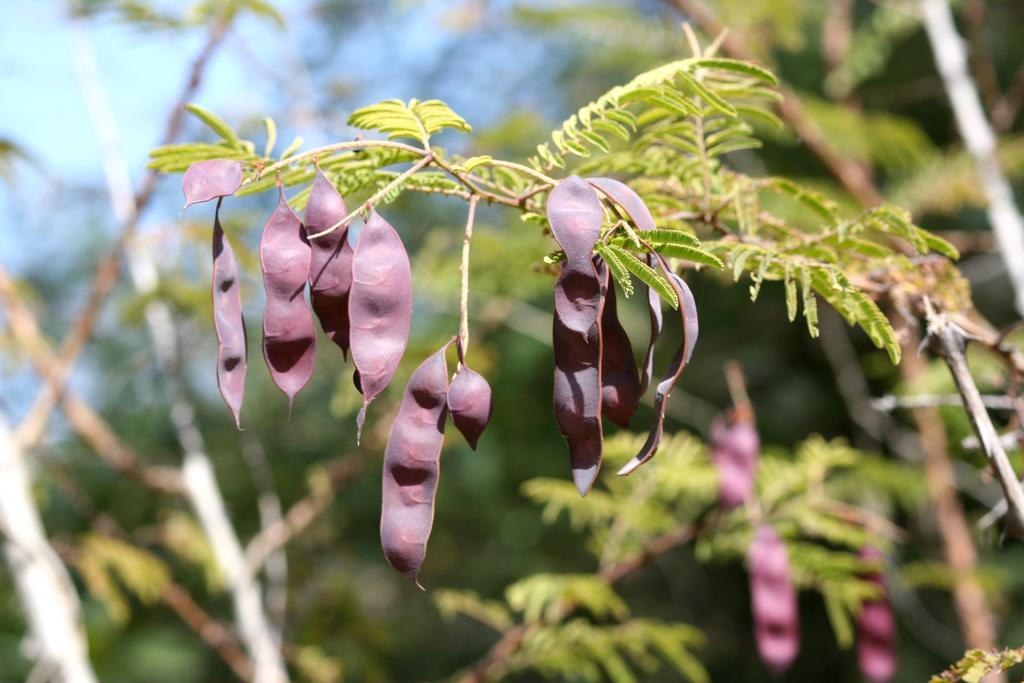Please provide a concise description of this image. In this image there are tamarind buds, leaves on the branch of a tree. 